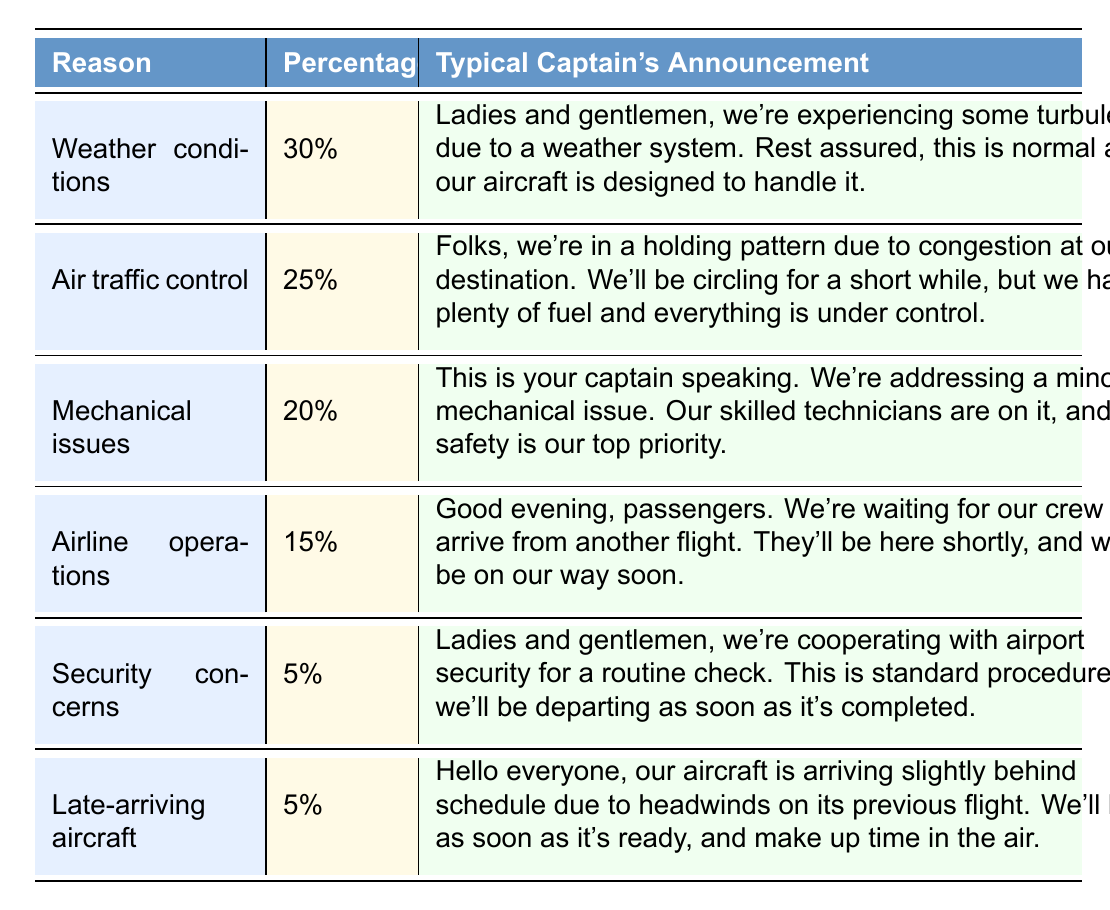What is the percentage of flight delays caused by weather conditions? According to the table, the percentage for weather conditions is clearly stated as 30%.
Answer: 30% Which reason has the highest percentage of delays? By comparing the percentages in the table, weather conditions at 30% is the highest, followed by air traffic control at 25%.
Answer: Weather conditions How many reasons for flight delays have a percentage of 5%? The table lists two reasons with a percentage of 5%: security concerns and late-arriving aircraft.
Answer: 2 What is the combined percentage of flight delays due to mechanical issues and airline operations? Mechanical issues account for 20%, and airline operations account for 15%. Adding these together gives 20 + 15 = 35%.
Answer: 35% Is the percentage of delays caused by air traffic control greater than that caused by airline operations? Air traffic control is 25%, and airline operations are 15%. As 25% is greater than 15%, the answer is yes.
Answer: Yes What is the total percentage of delays caused by factors other than weather? The non-weather factors are air traffic control (25%), mechanical issues (20%), airline operations (15%), security concerns (5%), and late-arriving aircraft (5%). Adding these gives 25 + 20 + 15 + 5 + 5 = 70%.
Answer: 70% Create a comparison: how much more likely is a flight delay due to mechanical issues than to security concerns? Mechanical issues account for 20%, while security concerns account for 5%. The difference is 20 - 5 = 15%. Hence, delays due to mechanical issues are 15% more likely than those due to security concerns.
Answer: 15% How does the percentage of flight delays due to late-arriving aircraft compare to the percentage due to weather conditions? Late-arriving aircraft are at 5%, while weather conditions are at 30%. Since 5% is far less than 30%, late-arriving aircraft is less frequent.
Answer: Less frequent What would be the typical captain's announcement for delays caused by airline operations? Referring to the table, the announcement states: "Good evening, passengers. We're waiting for our crew to arrive from another flight. They'll be here shortly, and we'll be on our way soon."
Answer: "Good evening, passengers. We're waiting for our crew to arrive from another flight. They'll be here shortly, and we'll be on our way soon." If a flight is delayed due to air traffic control, how long might passengers expect to wait? The captain's announcement for air traffic control mentions circling for a short while. It does not specify the exact time, but it indicates they have plenty of fuel and everything is under control.
Answer: A short while 